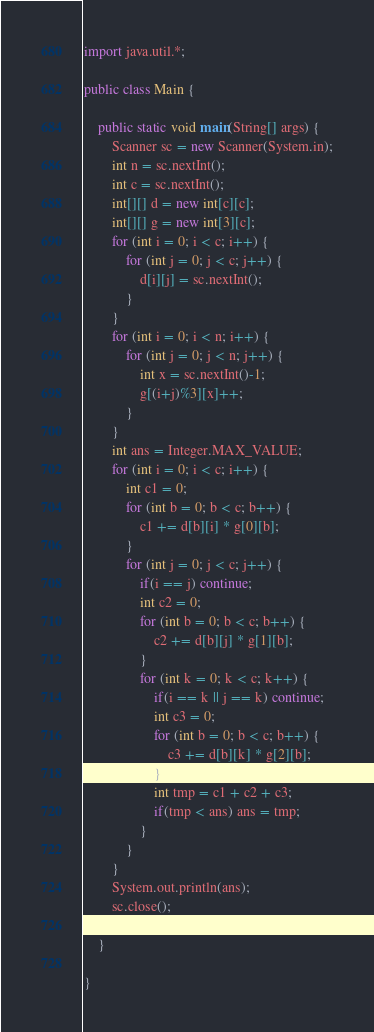Convert code to text. <code><loc_0><loc_0><loc_500><loc_500><_Java_>import java.util.*;

public class Main {

    public static void main(String[] args) {
        Scanner sc = new Scanner(System.in);
        int n = sc.nextInt();
        int c = sc.nextInt();
        int[][] d = new int[c][c];
        int[][] g = new int[3][c];
        for (int i = 0; i < c; i++) {
            for (int j = 0; j < c; j++) {
                d[i][j] = sc.nextInt();
            }
        }
        for (int i = 0; i < n; i++) {
            for (int j = 0; j < n; j++) {
                int x = sc.nextInt()-1;
                g[(i+j)%3][x]++;
            }
        }
        int ans = Integer.MAX_VALUE;
        for (int i = 0; i < c; i++) {
            int c1 = 0;
            for (int b = 0; b < c; b++) {
                c1 += d[b][i] * g[0][b];
            }
            for (int j = 0; j < c; j++) {
                if(i == j) continue;
                int c2 = 0;
                for (int b = 0; b < c; b++) {
                    c2 += d[b][j] * g[1][b];
                }
                for (int k = 0; k < c; k++) {
                    if(i == k || j == k) continue;
                    int c3 = 0;
                    for (int b = 0; b < c; b++) {
                        c3 += d[b][k] * g[2][b];
                    }
                    int tmp = c1 + c2 + c3;
                    if(tmp < ans) ans = tmp;
                }
            }
        }
        System.out.println(ans);
        sc.close();

    }

}
</code> 